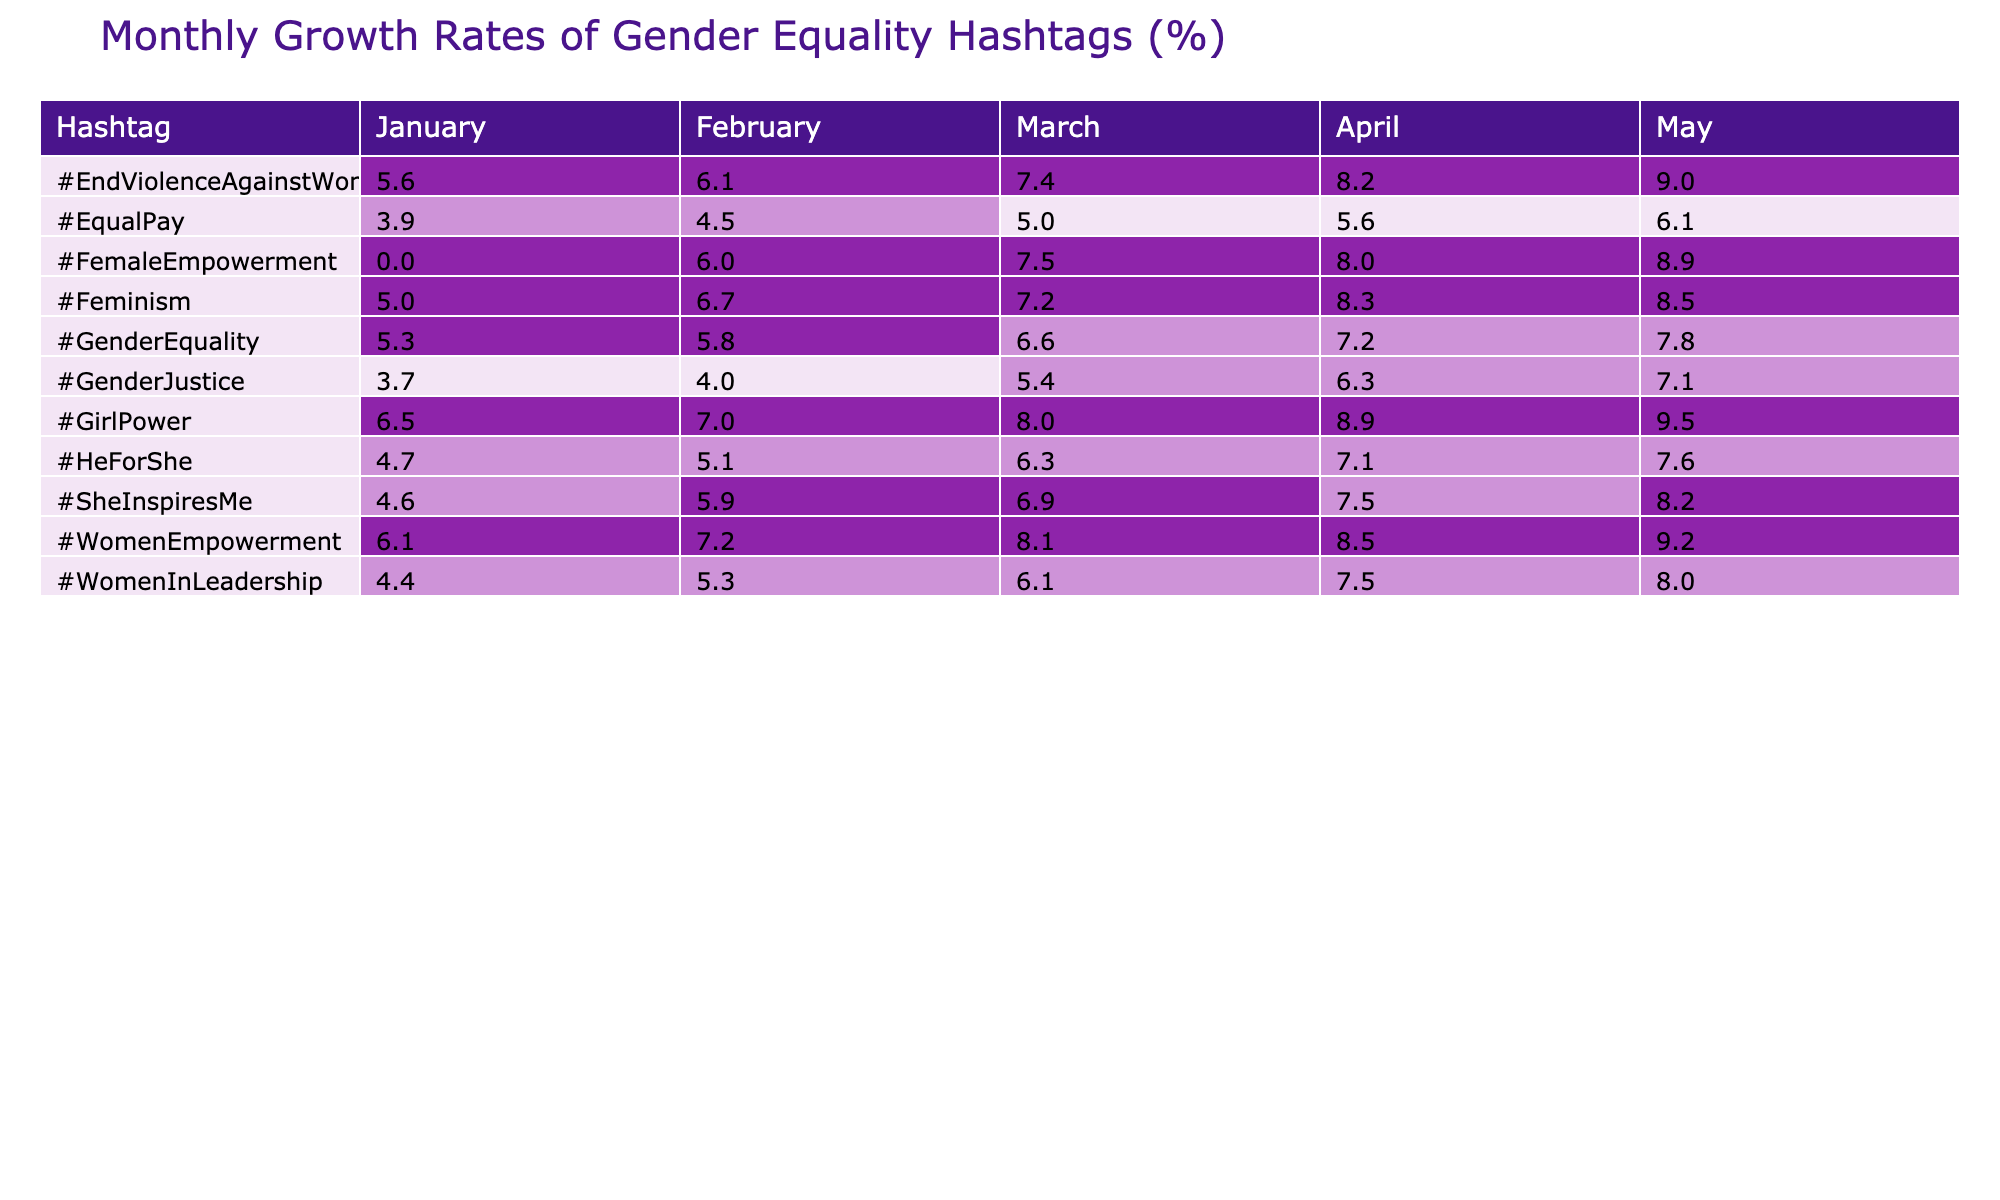What was the growth rate of the hashtag #WomenEmpowerment in March 2023? Looking at the March column in the table for the hashtag #WomenEmpowerment, the value is 8.1%.
Answer: 8.1% Which hashtag had the highest growth rate in April 2023? In the April column, by comparing the growth rates of all hashtags, #GirlPower has the highest value at 8.9%.
Answer: #GirlPower What is the average growth rate of the hashtag #EqualPay from January to May 2023? The growth rates for #EqualPay over the months are 3.9% (January), 4.5% (February), 5.0% (March), 5.6% (April), and 6.1% (May). Summing these gives 3.9 + 4.5 + 5.0 + 5.6 + 6.1 = 25.1%. Dividing by the number of months (5) results in an average of 25.1 / 5 = 5.02%.
Answer: 5.02% Did the hashtag #Feminism have a growing trend every month from January to May 2023? By checking the growth rates in the table, #Feminism had growth rates of 5.0%, 6.7%, 7.2%, 8.3%, and 8.5% in consecutive months, indicating it consistently increased, so the trend is upward every month.
Answer: Yes What was the total growth percentage for the hashtag #EndViolenceAgainstWomen from January to May 2023? The growth rates for #EndViolenceAgainstWomen are 5.6% (January), 6.1% (February), 7.4% (March), 8.2% (April), and 9.0% (May). Summing these yields 5.6 + 6.1 + 7.4 + 8.2 + 9.0 = 36.3%.
Answer: 36.3% How did the growth rate of #GirlPower compare to that of #GenderEquality in March 2023? In March 2023, #GirlPower had a growth rate of 8.0%, while #GenderEquality had a growth rate of 6.6%. Comparing these, #GirlPower's rate is higher by 8.0 - 6.6 = 1.4%.
Answer: Higher by 1.4% Which hashtag had a consistent growth rate increase by the largest percentage from January to May 2023? Evaluating each hashtag's growth rates, #WomenEmpowerment started at 6.1% in January and ended at 9.2% in May, a change of 3.1%. #GirlPower had an increase from 6.5% to 9.5%, an increase of 3.0%. The greatest increase came from #WomenEmpowerment.
Answer: #WomenEmpowerment Did any hashtags show a decrease in growth rate from one month to the next? Checking the table, all hashtags either increased or stayed the same; there are no instances where a hashtag’s growth rate decreased from one month to the next, indicating a continuous growth trend.
Answer: No 